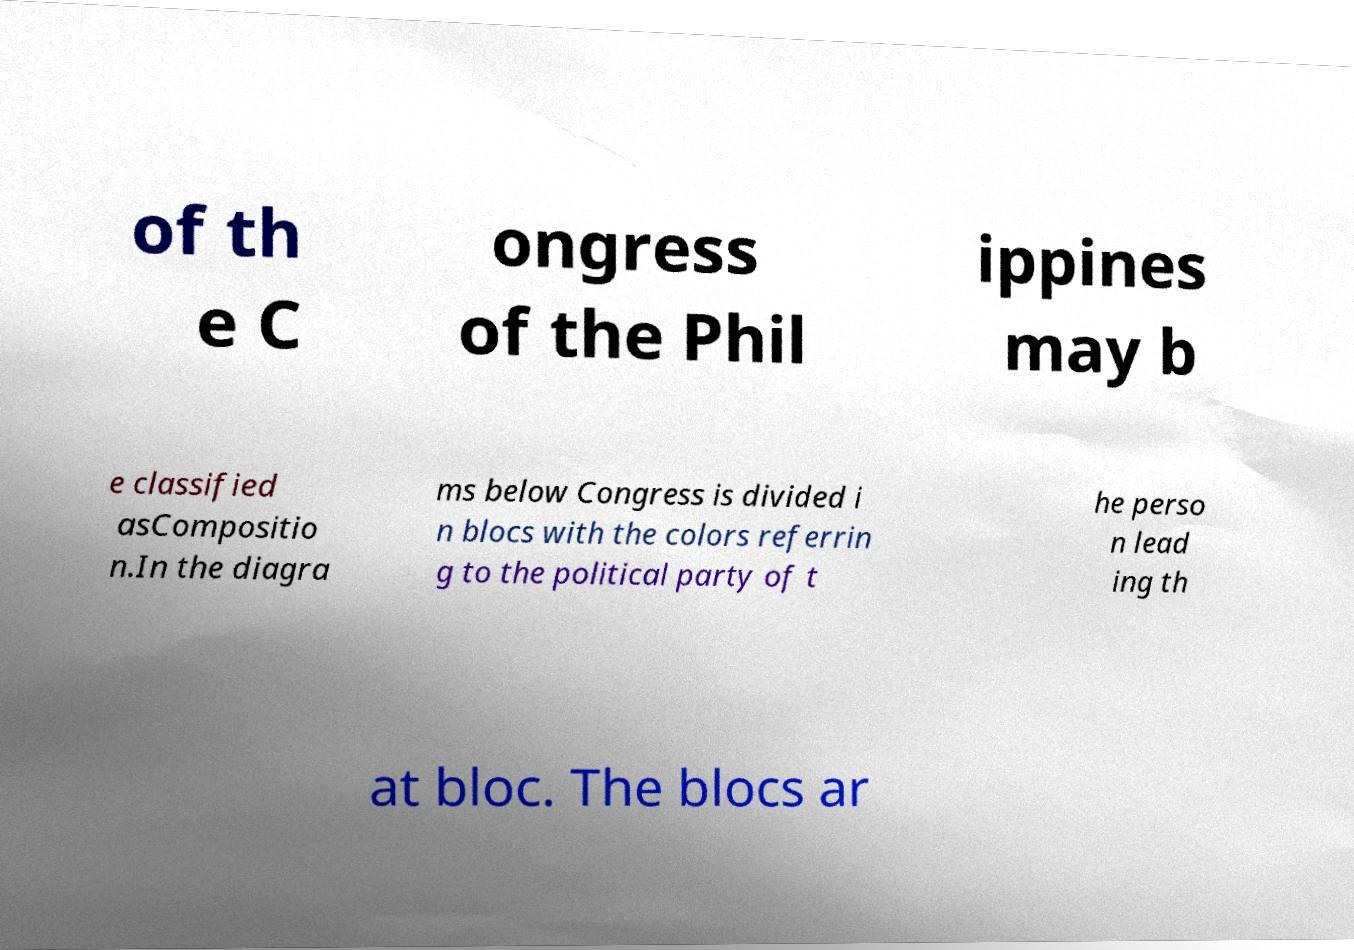What messages or text are displayed in this image? I need them in a readable, typed format. of th e C ongress of the Phil ippines may b e classified asCompositio n.In the diagra ms below Congress is divided i n blocs with the colors referrin g to the political party of t he perso n lead ing th at bloc. The blocs ar 